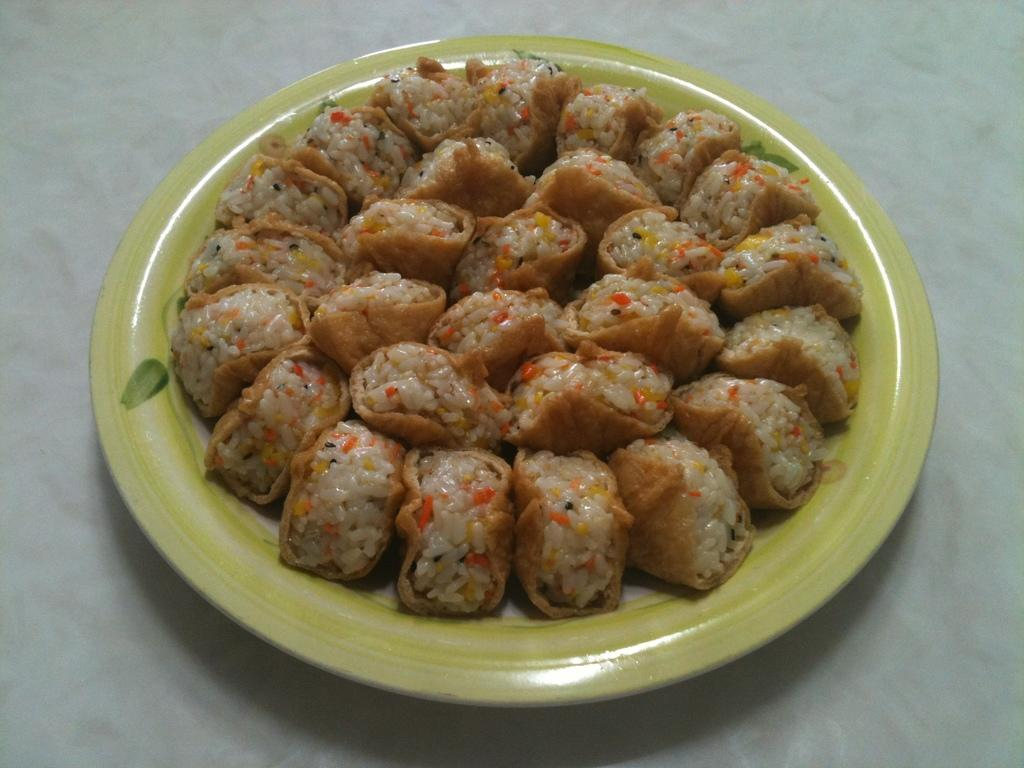What is the main subject of the image? There is a food item in the image. How is the food item presented in the image? The food item is on a plate. What color is the background of the image? The background of the image is white. What type of humor can be seen in the image? There is no humor present in the image; it features a food item on a plate with a white background. 